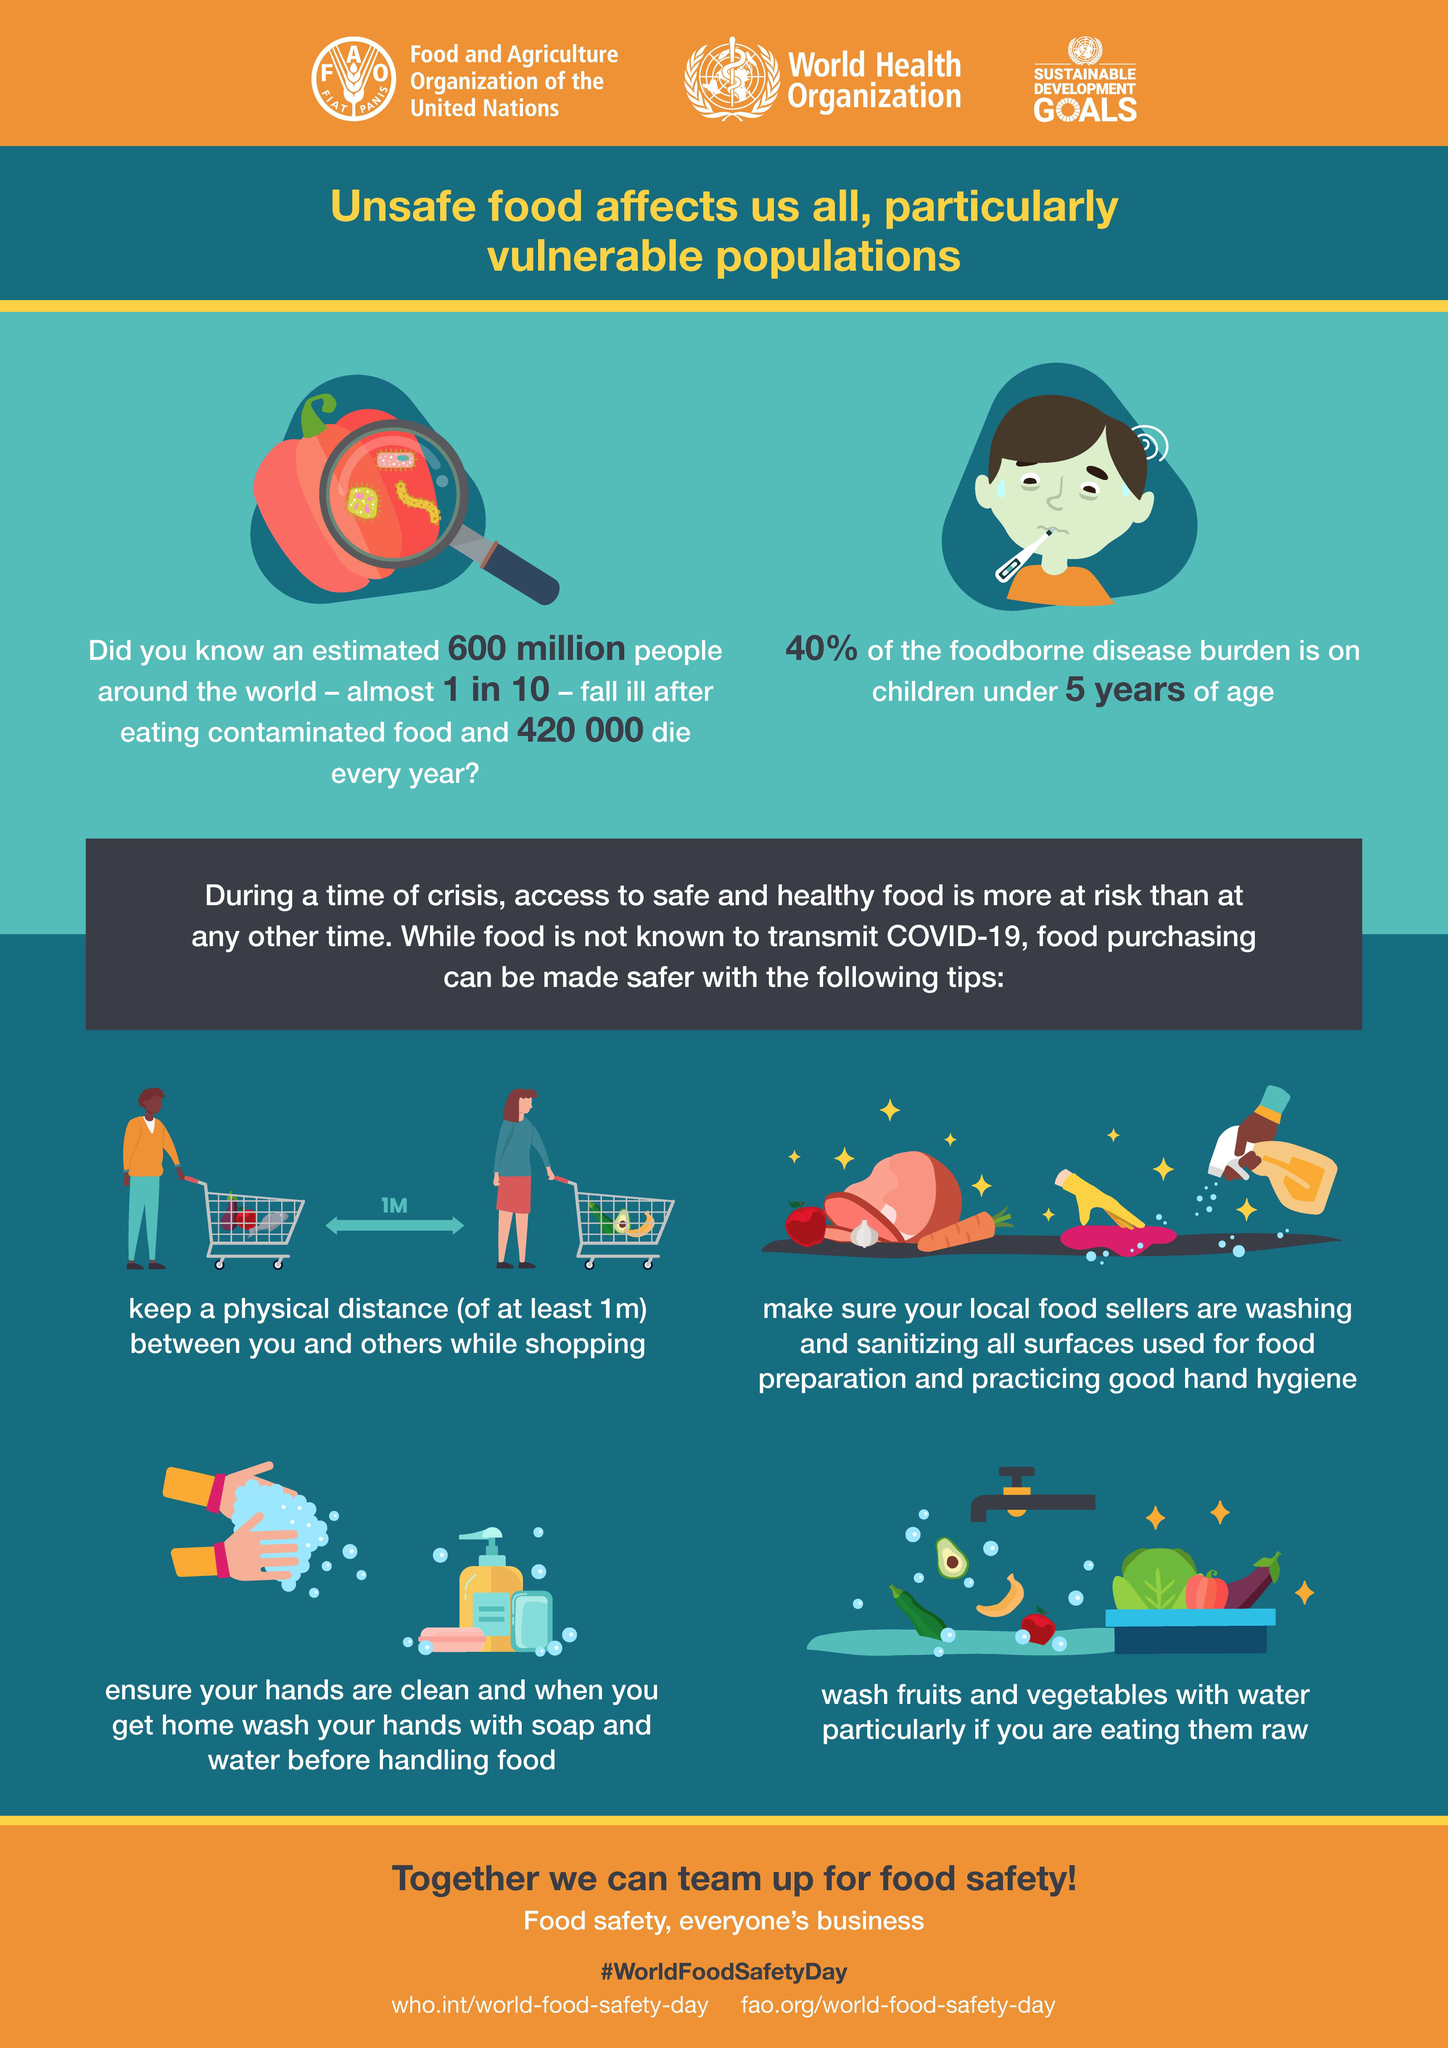Point out several critical features in this image. According to the infographic, it is recommended to maintain a physical distance of at least 1 meter while shopping to ensure safety. Children under the age of 5 are the most vulnerable population to foodborne diseases. According to estimates, approximately 600 million people become ill each year due to consuming unsafe food globally. According to estimates, approximately 420,000 people die each year due to the consumption of unsafe food. Consumption of contaminated food affects approximately 10% of the global population each year. 